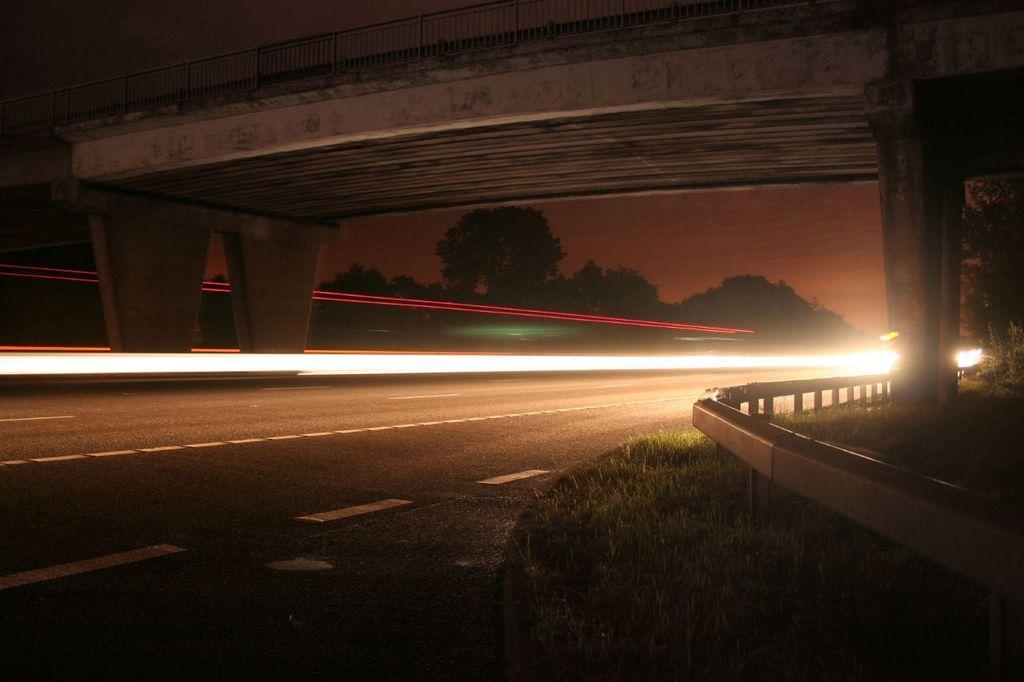In one or two sentences, can you explain what this image depicts? In this picture we can see the road, grass, fence, bridge, trees, lights and in the background we can see the sky. 